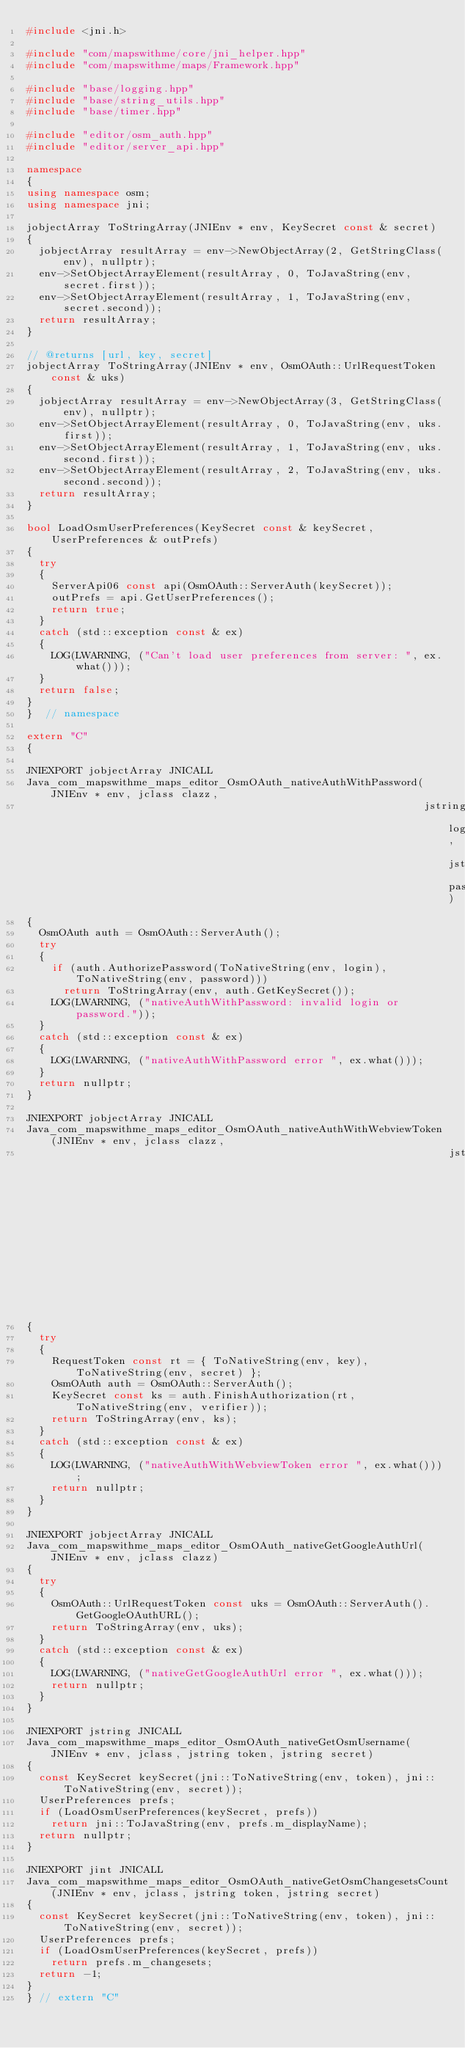<code> <loc_0><loc_0><loc_500><loc_500><_C++_>#include <jni.h>

#include "com/mapswithme/core/jni_helper.hpp"
#include "com/mapswithme/maps/Framework.hpp"

#include "base/logging.hpp"
#include "base/string_utils.hpp"
#include "base/timer.hpp"

#include "editor/osm_auth.hpp"
#include "editor/server_api.hpp"

namespace
{
using namespace osm;
using namespace jni;

jobjectArray ToStringArray(JNIEnv * env, KeySecret const & secret)
{
  jobjectArray resultArray = env->NewObjectArray(2, GetStringClass(env), nullptr);
  env->SetObjectArrayElement(resultArray, 0, ToJavaString(env, secret.first));
  env->SetObjectArrayElement(resultArray, 1, ToJavaString(env, secret.second));
  return resultArray;
}

// @returns [url, key, secret]
jobjectArray ToStringArray(JNIEnv * env, OsmOAuth::UrlRequestToken const & uks)
{
  jobjectArray resultArray = env->NewObjectArray(3, GetStringClass(env), nullptr);
  env->SetObjectArrayElement(resultArray, 0, ToJavaString(env, uks.first));
  env->SetObjectArrayElement(resultArray, 1, ToJavaString(env, uks.second.first));
  env->SetObjectArrayElement(resultArray, 2, ToJavaString(env, uks.second.second));
  return resultArray;
}

bool LoadOsmUserPreferences(KeySecret const & keySecret, UserPreferences & outPrefs)
{
  try
  {
    ServerApi06 const api(OsmOAuth::ServerAuth(keySecret));
    outPrefs = api.GetUserPreferences();
    return true;
  }
  catch (std::exception const & ex)
  {
    LOG(LWARNING, ("Can't load user preferences from server: ", ex.what()));
  }
  return false;
}
}  // namespace

extern "C"
{

JNIEXPORT jobjectArray JNICALL
Java_com_mapswithme_maps_editor_OsmOAuth_nativeAuthWithPassword(JNIEnv * env, jclass clazz,
                                                                jstring login, jstring password)
{
  OsmOAuth auth = OsmOAuth::ServerAuth();
  try
  {
    if (auth.AuthorizePassword(ToNativeString(env, login), ToNativeString(env, password)))
      return ToStringArray(env, auth.GetKeySecret());
    LOG(LWARNING, ("nativeAuthWithPassword: invalid login or password."));
  }
  catch (std::exception const & ex)
  {
    LOG(LWARNING, ("nativeAuthWithPassword error ", ex.what()));
  }
  return nullptr;
}

JNIEXPORT jobjectArray JNICALL
Java_com_mapswithme_maps_editor_OsmOAuth_nativeAuthWithWebviewToken(JNIEnv * env, jclass clazz,
                                                                    jstring key, jstring secret, jstring verifier)
{
  try
  {
    RequestToken const rt = { ToNativeString(env, key), ToNativeString(env, secret) };
    OsmOAuth auth = OsmOAuth::ServerAuth();
    KeySecret const ks = auth.FinishAuthorization(rt, ToNativeString(env, verifier));
    return ToStringArray(env, ks);
  }
  catch (std::exception const & ex)
  {
    LOG(LWARNING, ("nativeAuthWithWebviewToken error ", ex.what()));
    return nullptr;
  }
}

JNIEXPORT jobjectArray JNICALL
Java_com_mapswithme_maps_editor_OsmOAuth_nativeGetGoogleAuthUrl(JNIEnv * env, jclass clazz)
{
  try
  {
    OsmOAuth::UrlRequestToken const uks = OsmOAuth::ServerAuth().GetGoogleOAuthURL();
    return ToStringArray(env, uks);
  }
  catch (std::exception const & ex)
  {
    LOG(LWARNING, ("nativeGetGoogleAuthUrl error ", ex.what()));
    return nullptr;
  }
}

JNIEXPORT jstring JNICALL
Java_com_mapswithme_maps_editor_OsmOAuth_nativeGetOsmUsername(JNIEnv * env, jclass, jstring token, jstring secret)
{
  const KeySecret keySecret(jni::ToNativeString(env, token), jni::ToNativeString(env, secret));
  UserPreferences prefs;
  if (LoadOsmUserPreferences(keySecret, prefs))
    return jni::ToJavaString(env, prefs.m_displayName);
  return nullptr;
}

JNIEXPORT jint JNICALL
Java_com_mapswithme_maps_editor_OsmOAuth_nativeGetOsmChangesetsCount(JNIEnv * env, jclass, jstring token, jstring secret)
{
  const KeySecret keySecret(jni::ToNativeString(env, token), jni::ToNativeString(env, secret));
  UserPreferences prefs;
  if (LoadOsmUserPreferences(keySecret, prefs))
    return prefs.m_changesets;
  return -1;
}
} // extern "C"
</code> 